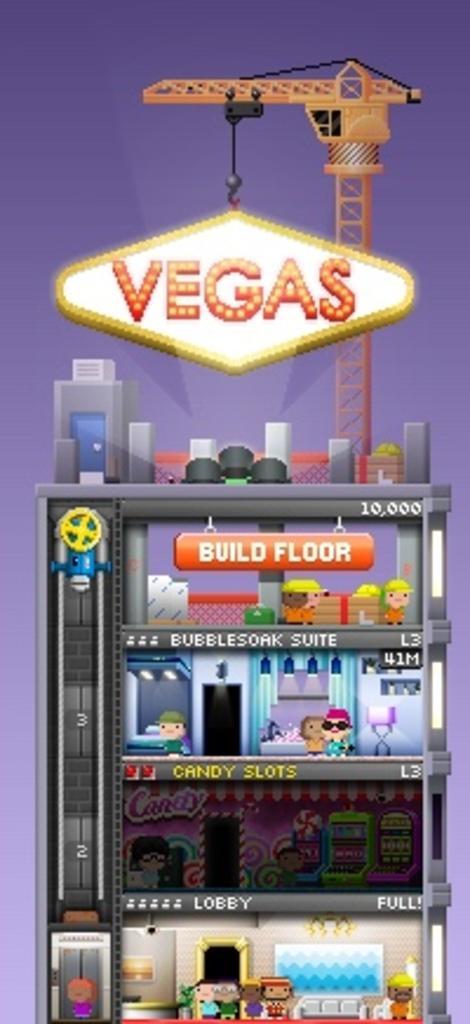How would you summarize this image in a sentence or two? In this image we can see animation relevant to that of fridge. And we can see some text written on it. And on the upper surface we can see the crane. 